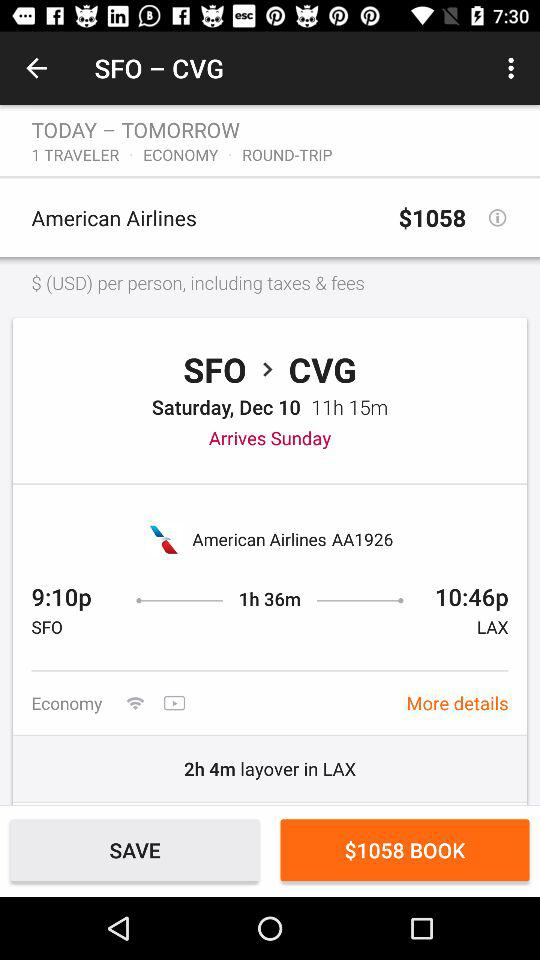How long is the layover in LAX?
Answer the question using a single word or phrase. 2h 4m 